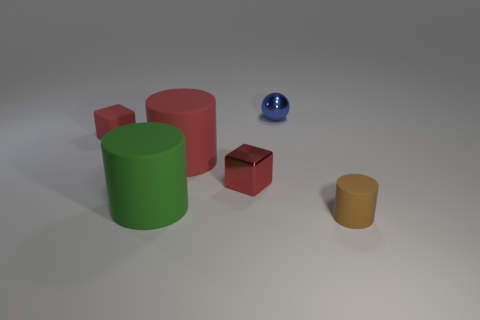What is the material of the other block that is the same color as the rubber cube?
Keep it short and to the point. Metal. What is the shape of the other tiny object that is made of the same material as the small blue object?
Offer a very short reply. Cube. There is a shiny ball; is it the same size as the cylinder behind the green rubber cylinder?
Your answer should be compact. No. Is there a small object of the same color as the metallic block?
Keep it short and to the point. Yes. Is there a tiny brown object?
Offer a very short reply. Yes. Does the large green matte object have the same shape as the red shiny thing?
Offer a terse response. No. What is the size of the cylinder that is the same color as the small shiny cube?
Keep it short and to the point. Large. There is a tiny block in front of the tiny red rubber object; how many red metal things are on the right side of it?
Offer a very short reply. 0. What number of things are in front of the red cylinder and to the left of the tiny brown object?
Your answer should be very brief. 2. What number of things are either blue things or rubber things to the right of the small shiny ball?
Provide a short and direct response. 2. 